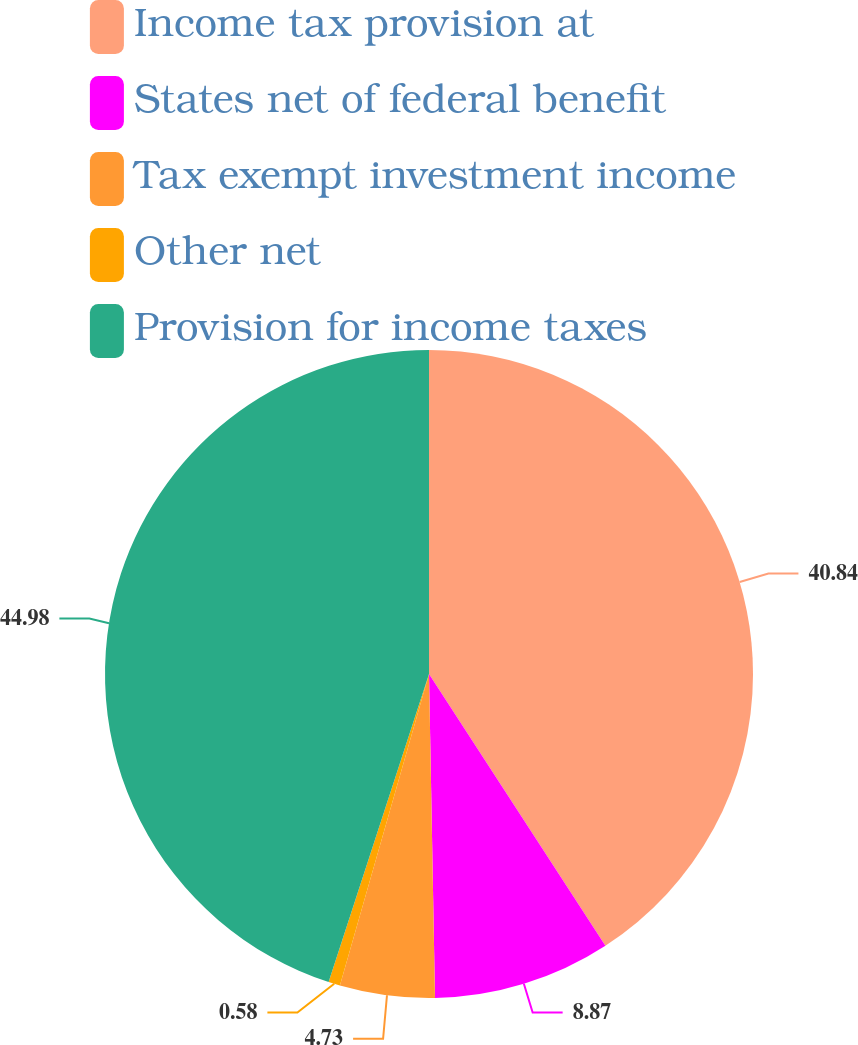Convert chart to OTSL. <chart><loc_0><loc_0><loc_500><loc_500><pie_chart><fcel>Income tax provision at<fcel>States net of federal benefit<fcel>Tax exempt investment income<fcel>Other net<fcel>Provision for income taxes<nl><fcel>40.84%<fcel>8.87%<fcel>4.73%<fcel>0.58%<fcel>44.99%<nl></chart> 